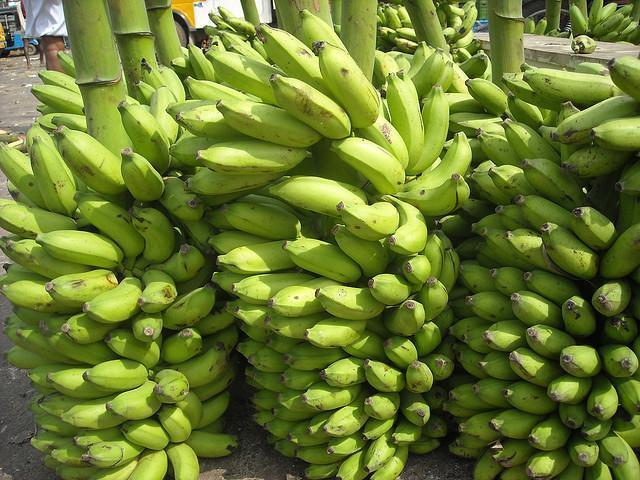How many bananas are in the picture?
Give a very brief answer. 3. 